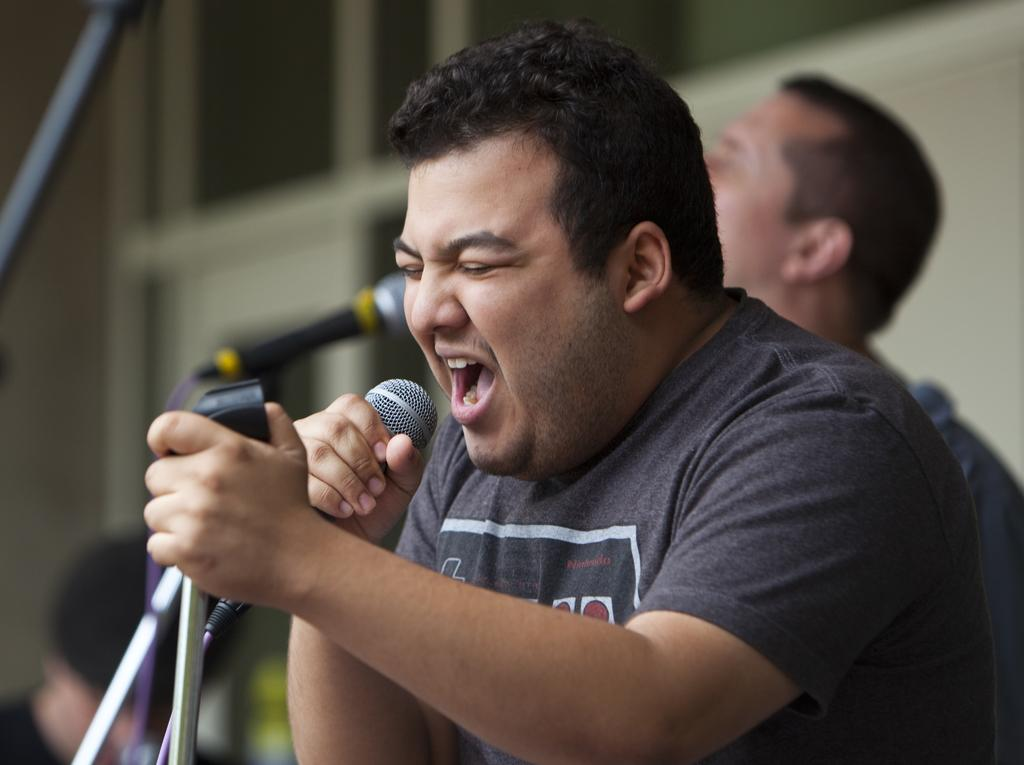What is the person in the foreground of the image holding? The person is holding a microphone in the image. Can you describe the person in the background of the image? There is another person in the background of the image, but no specific details are provided. What can be seen in the background of the image? There is a wall visible in the background of the image. What type of drum is the person playing in the image? There is no drum present in the image; the person is holding a microphone. Is the person driving a vehicle in the image? There is no indication of a vehicle or driving in the image. 